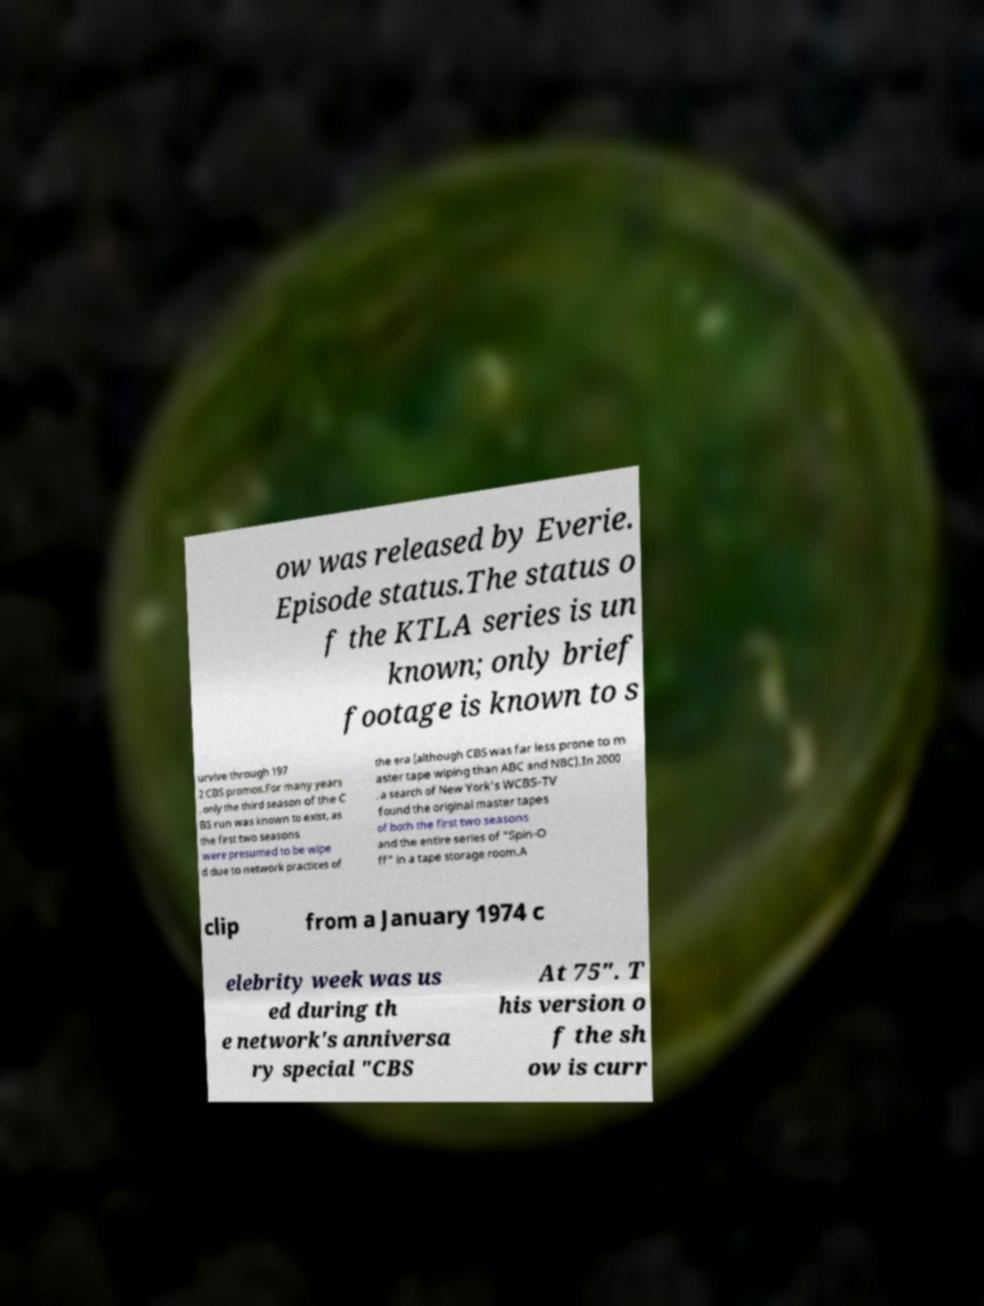Please read and relay the text visible in this image. What does it say? ow was released by Everie. Episode status.The status o f the KTLA series is un known; only brief footage is known to s urvive through 197 2 CBS promos.For many years , only the third season of the C BS run was known to exist, as the first two seasons were presumed to be wipe d due to network practices of the era (although CBS was far less prone to m aster tape wiping than ABC and NBC).In 2000 , a search of New York's WCBS-TV found the original master tapes of both the first two seasons and the entire series of "Spin-O ff" in a tape storage room.A clip from a January 1974 c elebrity week was us ed during th e network's anniversa ry special "CBS At 75". T his version o f the sh ow is curr 